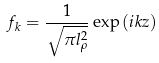<formula> <loc_0><loc_0><loc_500><loc_500>f _ { k } = \frac { 1 } { \sqrt { \pi l _ { \rho } ^ { 2 } } } \exp { ( i k z ) }</formula> 